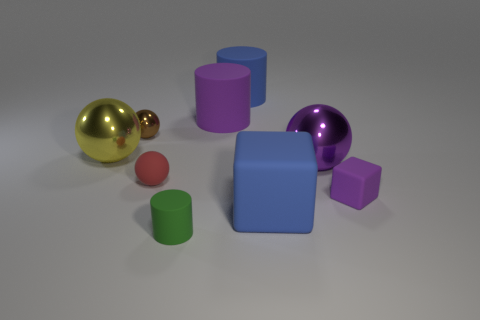Is there a metal sphere that has the same color as the tiny cube?
Provide a succinct answer. Yes. What number of tiny brown metallic things are the same shape as the purple metallic object?
Provide a short and direct response. 1. There is a thing that is behind the small metallic sphere and to the right of the purple rubber cylinder; what material is it?
Provide a short and direct response. Rubber. There is a purple cylinder; how many large metal things are in front of it?
Keep it short and to the point. 2. How many large gray metal balls are there?
Your answer should be very brief. 0. Does the yellow metal ball have the same size as the red object?
Provide a short and direct response. No. Is there a matte cylinder to the left of the big sphere that is on the right side of the purple rubber thing that is on the left side of the small purple rubber object?
Ensure brevity in your answer.  Yes. There is another tiny object that is the same shape as the brown thing; what material is it?
Provide a short and direct response. Rubber. There is a large thing on the left side of the brown sphere; what color is it?
Provide a short and direct response. Yellow. How big is the matte ball?
Ensure brevity in your answer.  Small. 